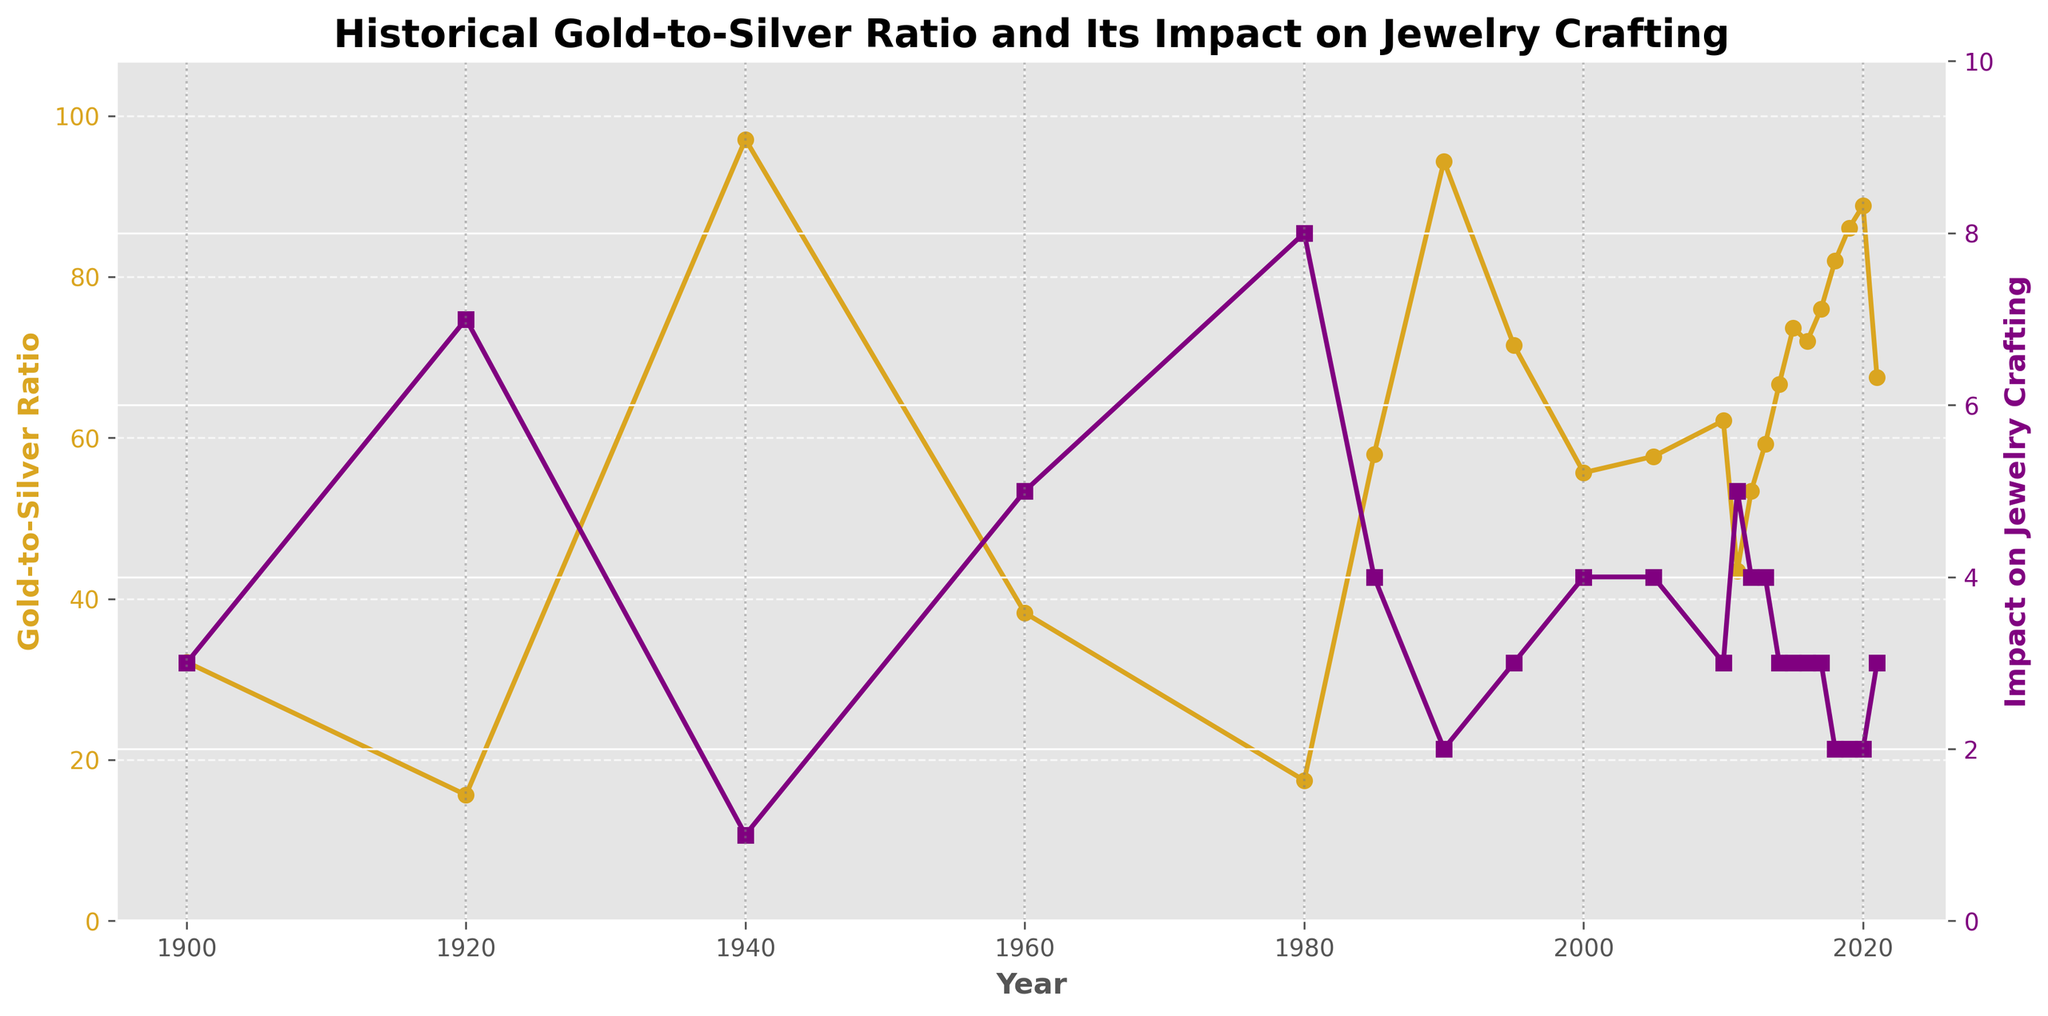What were the Gold-to-Silver Ratio and the Impact on Jewelry Crafting in 1980? The Gold-to-Silver Ratio line is marked with circles and is goldenrod in color. The Impact on Jewelry Crafting line is marked with square markers and is purple in color. Referring to the figure for the year 1980, the goldenrod line shows a value of 17.43 and the purple line shows a value of 8.
Answer: 17.43 and 8 Which year had the highest Gold-to-Silver Ratio? The goldenrod line represents the Gold-to-Silver Ratio, and it peaks at the highest point in 1940.
Answer: 1940 During which decade did the Impact on Jewelry Crafting reach its lowest and highest points according to the chart? Observing the purple line across the decades, the lowest impact is in the 1940s with a value of 1, and the highest impact is in the 1980s with a value of 8.
Answer: 1940s (lowest) and 1980s (highest) Compare the Gold-to-Silver Ratio in 1900 to that in 2020. Which year had a higher ratio and by how much? The figure shows that the Gold-to-Silver Ratio was 32.14 in 1900 and 88.86 in 2020. The ratio in 2020 was higher. Subtracting the two values gives 88.86 - 32.14 = 56.72.
Answer: 2020, by 56.72 What is the average Impact on Jewelry Crafting score from 2000 to 2020? The purple line represents the Impact on Jewelry Crafting. The scores from 2000 to 2020 are 4, 4, 3, 5, 4, 4, 3, 3, 3, 3, 2, 2, 2, 3. Adding these values and dividing by the number of years: (4+4+3+5+4+4+3+3+3+3+2+2+2+3) / 14 = 43 / 14 = 3.07.
Answer: 3.07 Was there any year when both the Gold-to-Silver Ratio and the Impact on Jewelry Crafting were at the same level? Observing both the goldenrod and purple lines across the chart, there is no year where both ratios intersect at the same value.
Answer: No In which periods did the Gold-to-Silver Ratio consistently increase or decrease? The figure shows that the Gold-to-Silver Ratio consistently increased from 1940 to 1960, decreased from 1960 to 1980, increased again from 1980 to 1990, decreased from 1990 to 2000, and increased once again from 2000 to 2019.
Answer: 1940-1960 (increase), 1960-1980 (decrease), 1980-1990 (increase), 1990-2000 (decrease), 2000-2019 (increase) In which year was the discrepancy between the Gold-to-Silver Ratio and the Impact on Jewelry Crafting score most pronounced? The maximum discrepancy occurred in 1940 where the Gold-to-Silver Ratio was 97.08 and the Impact on Jewelry Crafting was 1, indicating the most significant gap in the data points.
Answer: 1940 How did the significant dip in Gold-to-Silver ratio in 1980 affect jewelry crafting according to the chart? Referring to the goldenrod line, the ratio dipped significantly to 17.43 in 1980. The purple line for the same year shows an Impact on Jewelry Crafting score of 8, indicating a high impact on jewelry crafting.
Answer: High impact on jewelry crafting 